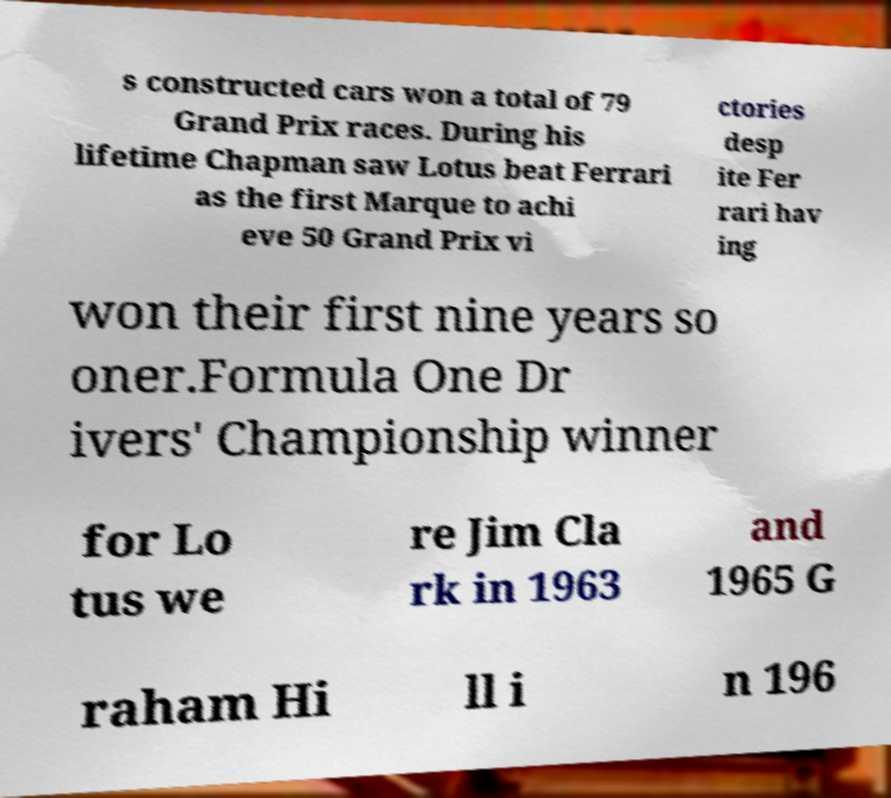There's text embedded in this image that I need extracted. Can you transcribe it verbatim? s constructed cars won a total of 79 Grand Prix races. During his lifetime Chapman saw Lotus beat Ferrari as the first Marque to achi eve 50 Grand Prix vi ctories desp ite Fer rari hav ing won their first nine years so oner.Formula One Dr ivers' Championship winner for Lo tus we re Jim Cla rk in 1963 and 1965 G raham Hi ll i n 196 